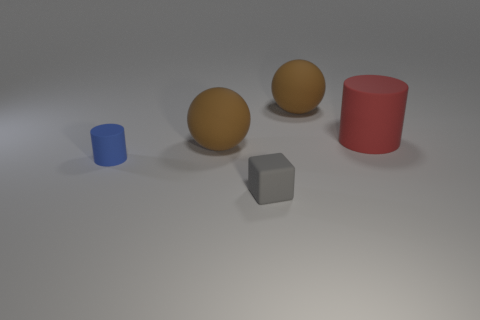Subtract all red cylinders. How many cylinders are left? 1 Add 3 yellow shiny cylinders. How many objects exist? 8 Subtract 1 cubes. How many cubes are left? 0 Subtract all cubes. How many objects are left? 4 Subtract all brown cylinders. Subtract all red spheres. How many cylinders are left? 2 Subtract all red rubber cylinders. Subtract all big purple spheres. How many objects are left? 4 Add 1 brown rubber objects. How many brown rubber objects are left? 3 Add 2 small gray matte things. How many small gray matte things exist? 3 Subtract 0 brown cylinders. How many objects are left? 5 